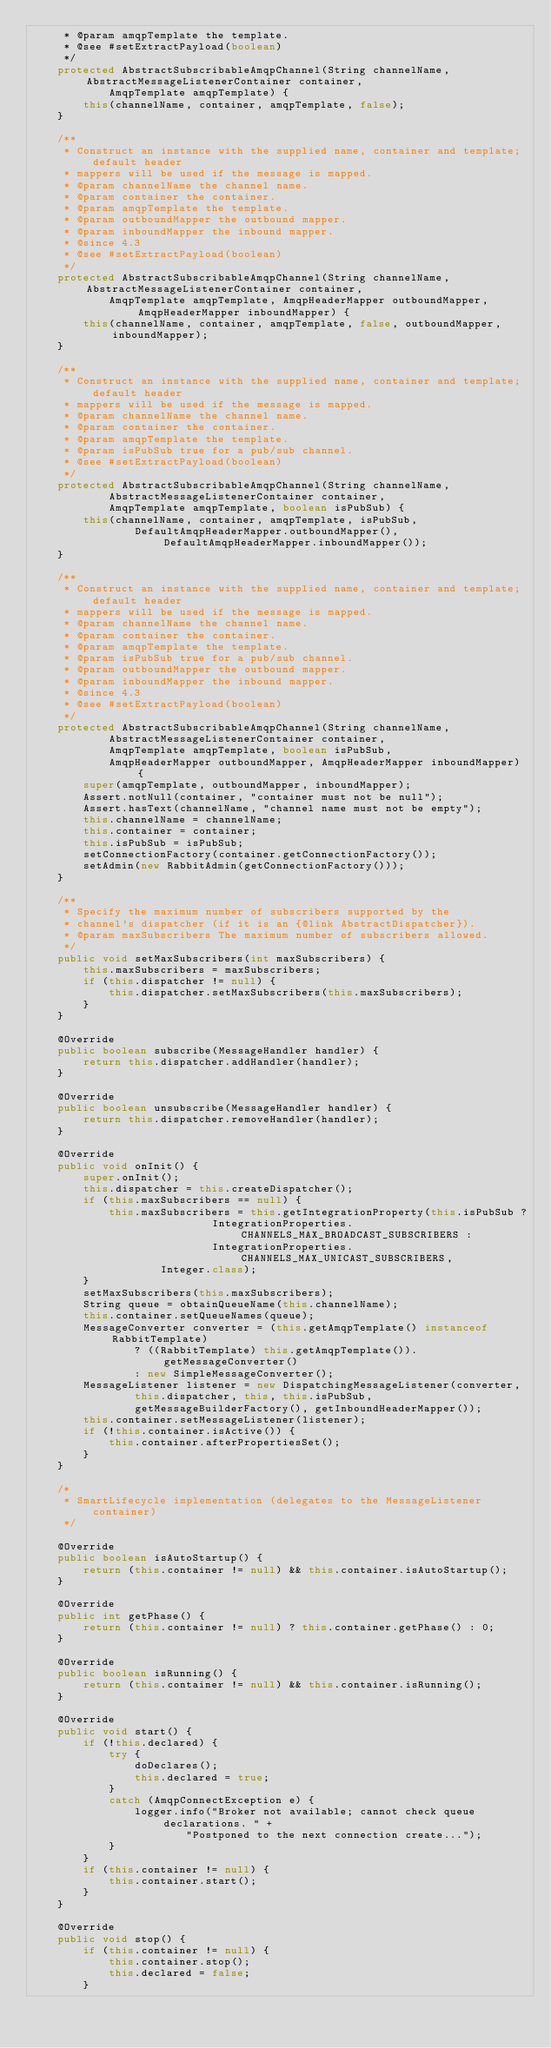<code> <loc_0><loc_0><loc_500><loc_500><_Java_>	 * @param amqpTemplate the template.
	 * @see #setExtractPayload(boolean)
	 */
	protected AbstractSubscribableAmqpChannel(String channelName, AbstractMessageListenerContainer container,
			AmqpTemplate amqpTemplate) {
		this(channelName, container, amqpTemplate, false);
	}

	/**
	 * Construct an instance with the supplied name, container and template; default header
	 * mappers will be used if the message is mapped.
	 * @param channelName the channel name.
	 * @param container the container.
	 * @param amqpTemplate the template.
	 * @param outboundMapper the outbound mapper.
	 * @param inboundMapper the inbound mapper.
	 * @since 4.3
	 * @see #setExtractPayload(boolean)
	 */
	protected AbstractSubscribableAmqpChannel(String channelName, AbstractMessageListenerContainer container,
			AmqpTemplate amqpTemplate, AmqpHeaderMapper outboundMapper, AmqpHeaderMapper inboundMapper) {
		this(channelName, container, amqpTemplate, false, outboundMapper, inboundMapper);
	}

	/**
	 * Construct an instance with the supplied name, container and template; default header
	 * mappers will be used if the message is mapped.
	 * @param channelName the channel name.
	 * @param container the container.
	 * @param amqpTemplate the template.
	 * @param isPubSub true for a pub/sub channel.
	 * @see #setExtractPayload(boolean)
	 */
	protected AbstractSubscribableAmqpChannel(String channelName,
			AbstractMessageListenerContainer container,
			AmqpTemplate amqpTemplate, boolean isPubSub) {
		this(channelName, container, amqpTemplate, isPubSub,
				DefaultAmqpHeaderMapper.outboundMapper(), DefaultAmqpHeaderMapper.inboundMapper());
	}

	/**
	 * Construct an instance with the supplied name, container and template; default header
	 * mappers will be used if the message is mapped.
	 * @param channelName the channel name.
	 * @param container the container.
	 * @param amqpTemplate the template.
	 * @param isPubSub true for a pub/sub channel.
	 * @param outboundMapper the outbound mapper.
	 * @param inboundMapper the inbound mapper.
	 * @since 4.3
	 * @see #setExtractPayload(boolean)
	 */
	protected AbstractSubscribableAmqpChannel(String channelName,
			AbstractMessageListenerContainer container,
			AmqpTemplate amqpTemplate, boolean isPubSub,
			AmqpHeaderMapper outboundMapper, AmqpHeaderMapper inboundMapper) {
		super(amqpTemplate, outboundMapper, inboundMapper);
		Assert.notNull(container, "container must not be null");
		Assert.hasText(channelName, "channel name must not be empty");
		this.channelName = channelName;
		this.container = container;
		this.isPubSub = isPubSub;
		setConnectionFactory(container.getConnectionFactory());
		setAdmin(new RabbitAdmin(getConnectionFactory()));
	}

	/**
	 * Specify the maximum number of subscribers supported by the
	 * channel's dispatcher (if it is an {@link AbstractDispatcher}).
	 * @param maxSubscribers The maximum number of subscribers allowed.
	 */
	public void setMaxSubscribers(int maxSubscribers) {
		this.maxSubscribers = maxSubscribers;
		if (this.dispatcher != null) {
			this.dispatcher.setMaxSubscribers(this.maxSubscribers);
		}
	}

	@Override
	public boolean subscribe(MessageHandler handler) {
		return this.dispatcher.addHandler(handler);
	}

	@Override
	public boolean unsubscribe(MessageHandler handler) {
		return this.dispatcher.removeHandler(handler);
	}

	@Override
	public void onInit() {
		super.onInit();
		this.dispatcher = this.createDispatcher();
		if (this.maxSubscribers == null) {
			this.maxSubscribers = this.getIntegrationProperty(this.isPubSub ?
							IntegrationProperties.CHANNELS_MAX_BROADCAST_SUBSCRIBERS :
							IntegrationProperties.CHANNELS_MAX_UNICAST_SUBSCRIBERS,
					Integer.class);
		}
		setMaxSubscribers(this.maxSubscribers);
		String queue = obtainQueueName(this.channelName);
		this.container.setQueueNames(queue);
		MessageConverter converter = (this.getAmqpTemplate() instanceof RabbitTemplate)
				? ((RabbitTemplate) this.getAmqpTemplate()).getMessageConverter()
				: new SimpleMessageConverter();
		MessageListener listener = new DispatchingMessageListener(converter,
				this.dispatcher, this, this.isPubSub,
				getMessageBuilderFactory(), getInboundHeaderMapper());
		this.container.setMessageListener(listener);
		if (!this.container.isActive()) {
			this.container.afterPropertiesSet();
		}
	}

	/*
	 * SmartLifecycle implementation (delegates to the MessageListener container)
	 */

	@Override
	public boolean isAutoStartup() {
		return (this.container != null) && this.container.isAutoStartup();
	}

	@Override
	public int getPhase() {
		return (this.container != null) ? this.container.getPhase() : 0;
	}

	@Override
	public boolean isRunning() {
		return (this.container != null) && this.container.isRunning();
	}

	@Override
	public void start() {
		if (!this.declared) {
			try {
				doDeclares();
				this.declared = true;
			}
			catch (AmqpConnectException e) {
				logger.info("Broker not available; cannot check queue declarations. " +
						"Postponed to the next connection create...");
			}
		}
		if (this.container != null) {
			this.container.start();
		}
	}

	@Override
	public void stop() {
		if (this.container != null) {
			this.container.stop();
			this.declared = false;
		}</code> 